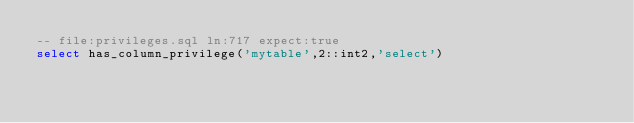<code> <loc_0><loc_0><loc_500><loc_500><_SQL_>-- file:privileges.sql ln:717 expect:true
select has_column_privilege('mytable',2::int2,'select')
</code> 